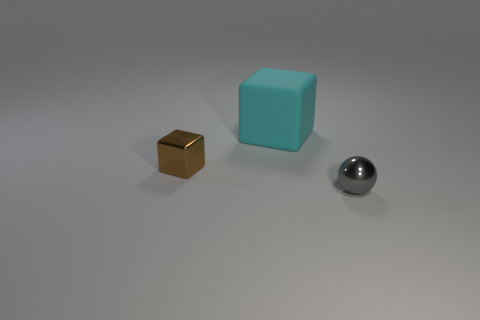Is there any other thing that has the same material as the big cyan cube?
Ensure brevity in your answer.  No. There is a thing that is to the right of the object that is behind the brown thing; what is its size?
Provide a succinct answer. Small. Are there any gray things that have the same size as the metallic block?
Your answer should be compact. Yes. There is a thing in front of the brown cube; is its size the same as the shiny object that is behind the small gray metal thing?
Offer a very short reply. Yes. What shape is the small shiny thing left of the thing on the right side of the big matte block?
Your answer should be compact. Cube. There is a big cyan thing; what number of brown objects are behind it?
Give a very brief answer. 0. What color is the ball that is made of the same material as the tiny cube?
Offer a very short reply. Gray. Do the metallic cube and the metallic object on the right side of the large cyan thing have the same size?
Offer a terse response. Yes. What is the size of the shiny thing that is in front of the shiny object behind the small shiny object right of the large cyan object?
Give a very brief answer. Small. What number of matte objects are gray balls or cyan cubes?
Ensure brevity in your answer.  1. 